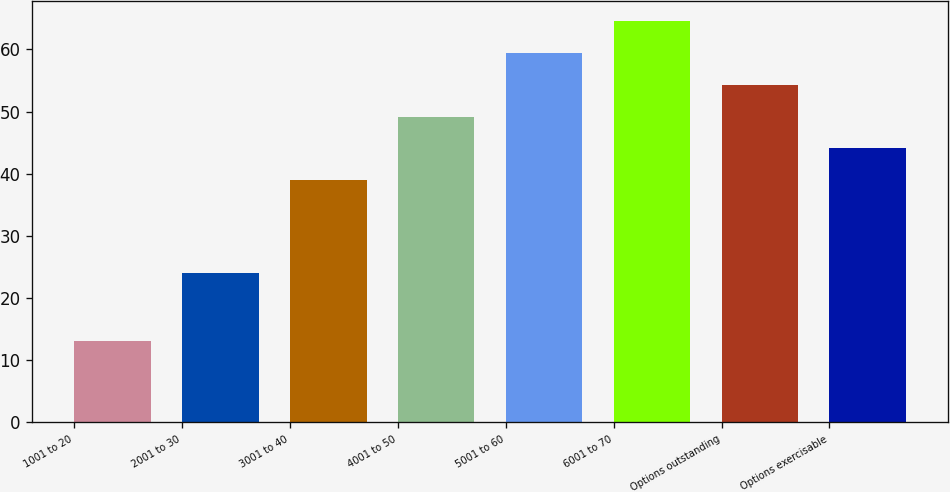Convert chart. <chart><loc_0><loc_0><loc_500><loc_500><bar_chart><fcel>1001 to 20<fcel>2001 to 30<fcel>3001 to 40<fcel>4001 to 50<fcel>5001 to 60<fcel>6001 to 70<fcel>Options outstanding<fcel>Options exercisable<nl><fcel>13<fcel>24<fcel>39<fcel>49.2<fcel>59.4<fcel>64.5<fcel>54.3<fcel>44.1<nl></chart> 